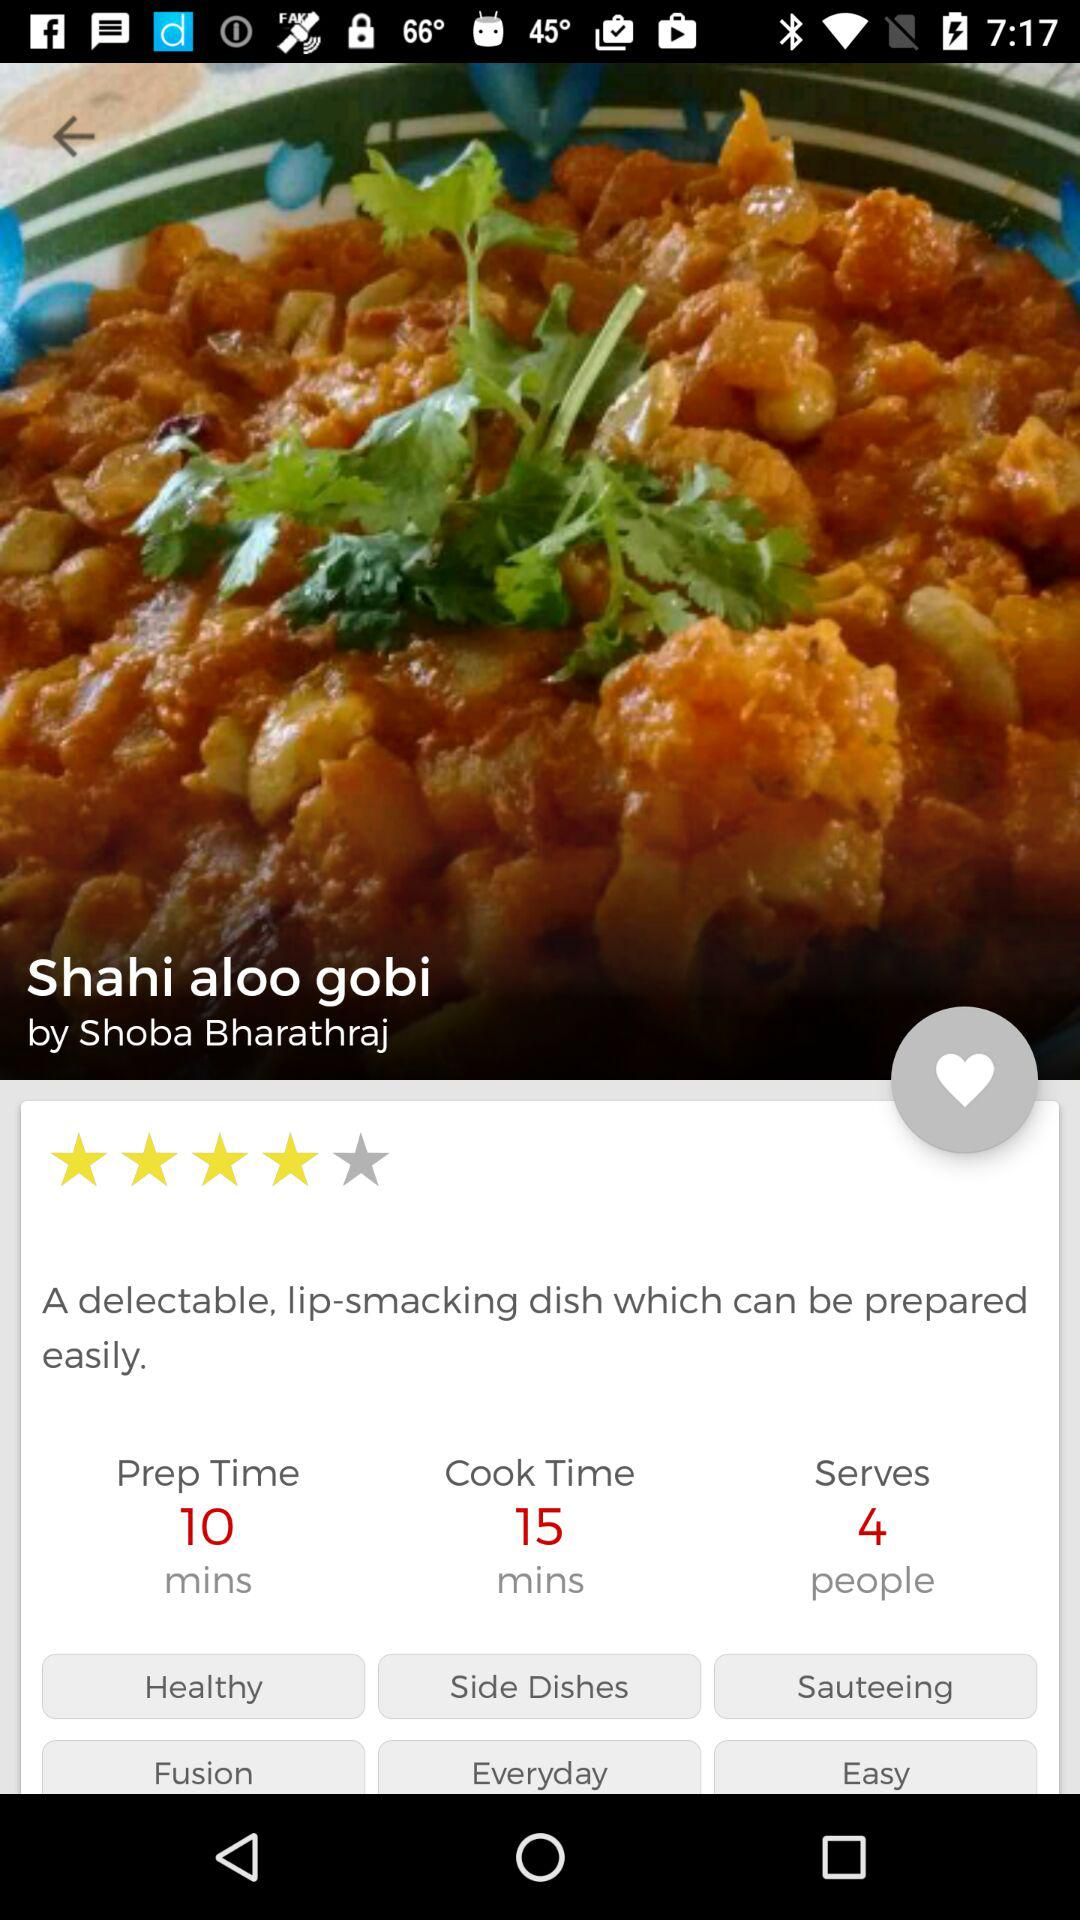What is the rating for "Shahi aloo gobi"? The rating is 4 stars. 